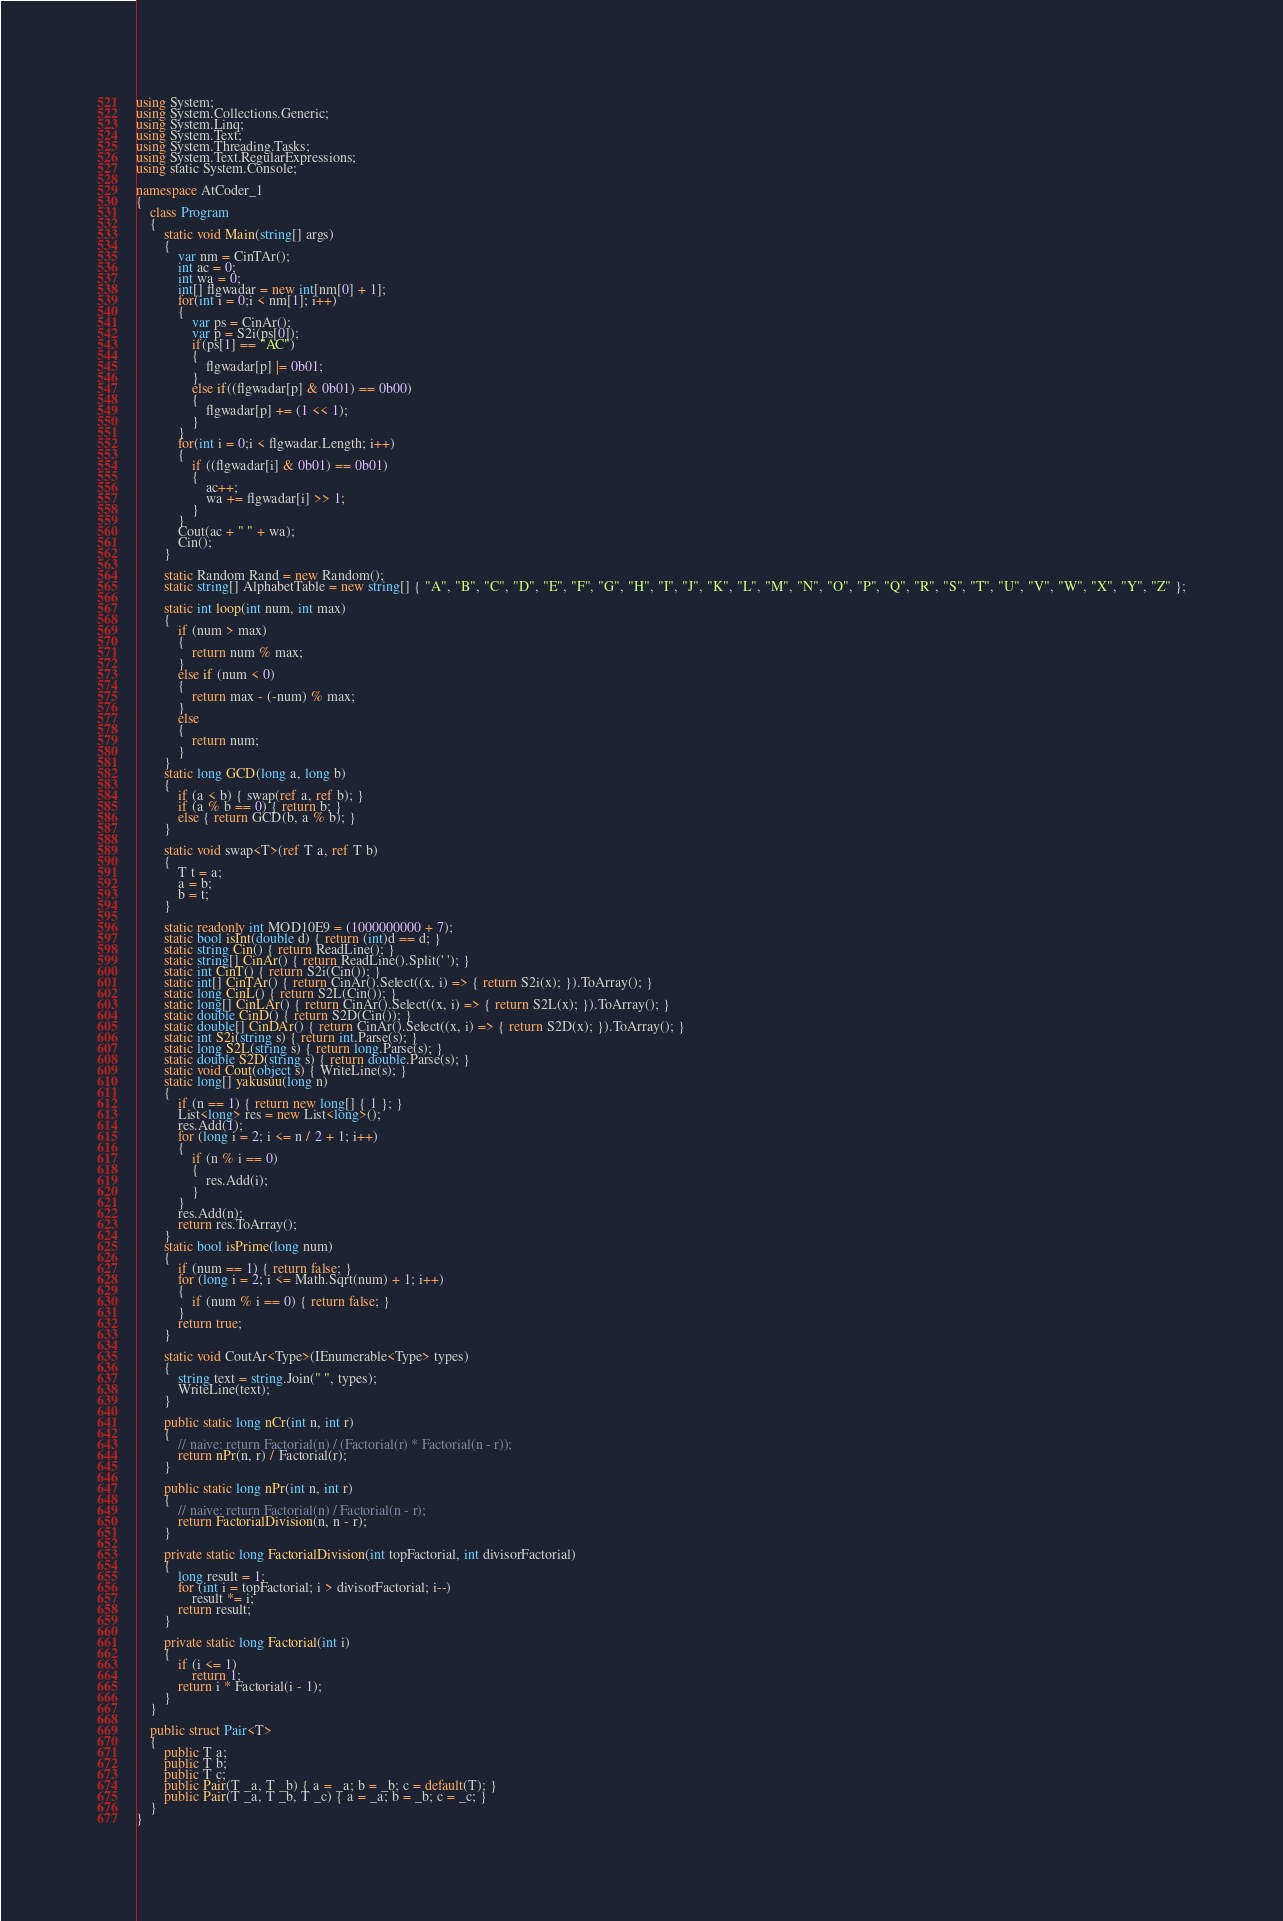Convert code to text. <code><loc_0><loc_0><loc_500><loc_500><_C#_>using System;
using System.Collections.Generic;
using System.Linq;
using System.Text;
using System.Threading.Tasks;
using System.Text.RegularExpressions;
using static System.Console;

namespace AtCoder_1
{
    class Program
    {
        static void Main(string[] args)
        {
            var nm = CinTAr();
            int ac = 0;
            int wa = 0;
            int[] flgwadar = new int[nm[0] + 1];
            for(int i = 0;i < nm[1]; i++)
            {
                var ps = CinAr();
                var p = S2i(ps[0]);
                if(ps[1] == "AC")
                {
                    flgwadar[p] |= 0b01;
                }
                else if((flgwadar[p] & 0b01) == 0b00)
                {
                    flgwadar[p] += (1 << 1);
                }
            }
            for(int i = 0;i < flgwadar.Length; i++)
            {
                if ((flgwadar[i] & 0b01) == 0b01)
                {
                    ac++;
                    wa += flgwadar[i] >> 1;
                }
            }
            Cout(ac + " " + wa);
            Cin();
        }

        static Random Rand = new Random();
        static string[] AlphabetTable = new string[] { "A", "B", "C", "D", "E", "F", "G", "H", "I", "J", "K", "L", "M", "N", "O", "P", "Q", "R", "S", "T", "U", "V", "W", "X", "Y", "Z" };

        static int loop(int num, int max)
        {
            if (num > max)
            {
                return num % max;
            }
            else if (num < 0)
            {
                return max - (-num) % max;
            }
            else
            {
                return num;
            }
        }
        static long GCD(long a, long b)
        {
            if (a < b) { swap(ref a, ref b); }
            if (a % b == 0) { return b; }
            else { return GCD(b, a % b); }
        }

        static void swap<T>(ref T a, ref T b)
        {
            T t = a;
            a = b;
            b = t;
        }

        static readonly int MOD10E9 = (1000000000 + 7);
        static bool isInt(double d) { return (int)d == d; }
        static string Cin() { return ReadLine(); }
        static string[] CinAr() { return ReadLine().Split(' '); }
        static int CinT() { return S2i(Cin()); }
        static int[] CinTAr() { return CinAr().Select((x, i) => { return S2i(x); }).ToArray(); }
        static long CinL() { return S2L(Cin()); }
        static long[] CinLAr() { return CinAr().Select((x, i) => { return S2L(x); }).ToArray(); }
        static double CinD() { return S2D(Cin()); }
        static double[] CinDAr() { return CinAr().Select((x, i) => { return S2D(x); }).ToArray(); }
        static int S2i(string s) { return int.Parse(s); }
        static long S2L(string s) { return long.Parse(s); }
        static double S2D(string s) { return double.Parse(s); }
        static void Cout(object s) { WriteLine(s); }
        static long[] yakusuu(long n)
        {
            if (n == 1) { return new long[] { 1 }; }
            List<long> res = new List<long>();
            res.Add(1);
            for (long i = 2; i <= n / 2 + 1; i++)
            {
                if (n % i == 0)
                {
                    res.Add(i);
                }
            }
            res.Add(n);
            return res.ToArray();
        }
        static bool isPrime(long num)
        {
            if (num == 1) { return false; }
            for (long i = 2; i <= Math.Sqrt(num) + 1; i++)
            {
                if (num % i == 0) { return false; }
            }
            return true;
        }

        static void CoutAr<Type>(IEnumerable<Type> types)
        {
            string text = string.Join(" ", types);
            WriteLine(text);
        }

        public static long nCr(int n, int r)
        {
            // naive: return Factorial(n) / (Factorial(r) * Factorial(n - r));
            return nPr(n, r) / Factorial(r);
        }

        public static long nPr(int n, int r)
        {
            // naive: return Factorial(n) / Factorial(n - r);
            return FactorialDivision(n, n - r);
        }

        private static long FactorialDivision(int topFactorial, int divisorFactorial)
        {
            long result = 1;
            for (int i = topFactorial; i > divisorFactorial; i--)
                result *= i;
            return result;
        }

        private static long Factorial(int i)
        {
            if (i <= 1)
                return 1;
            return i * Factorial(i - 1);
        }
    }

    public struct Pair<T>
    {
        public T a;
        public T b;
        public T c;
        public Pair(T _a, T _b) { a = _a; b = _b; c = default(T); }
        public Pair(T _a, T _b, T _c) { a = _a; b = _b; c = _c; }
    }
}
</code> 